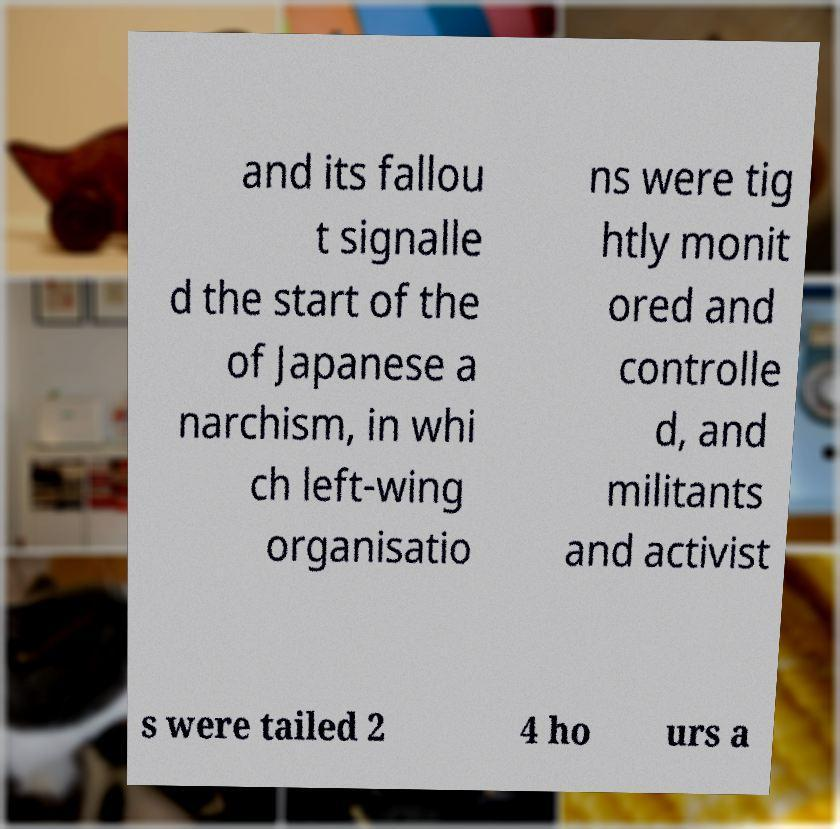What messages or text are displayed in this image? I need them in a readable, typed format. and its fallou t signalle d the start of the of Japanese a narchism, in whi ch left-wing organisatio ns were tig htly monit ored and controlle d, and militants and activist s were tailed 2 4 ho urs a 